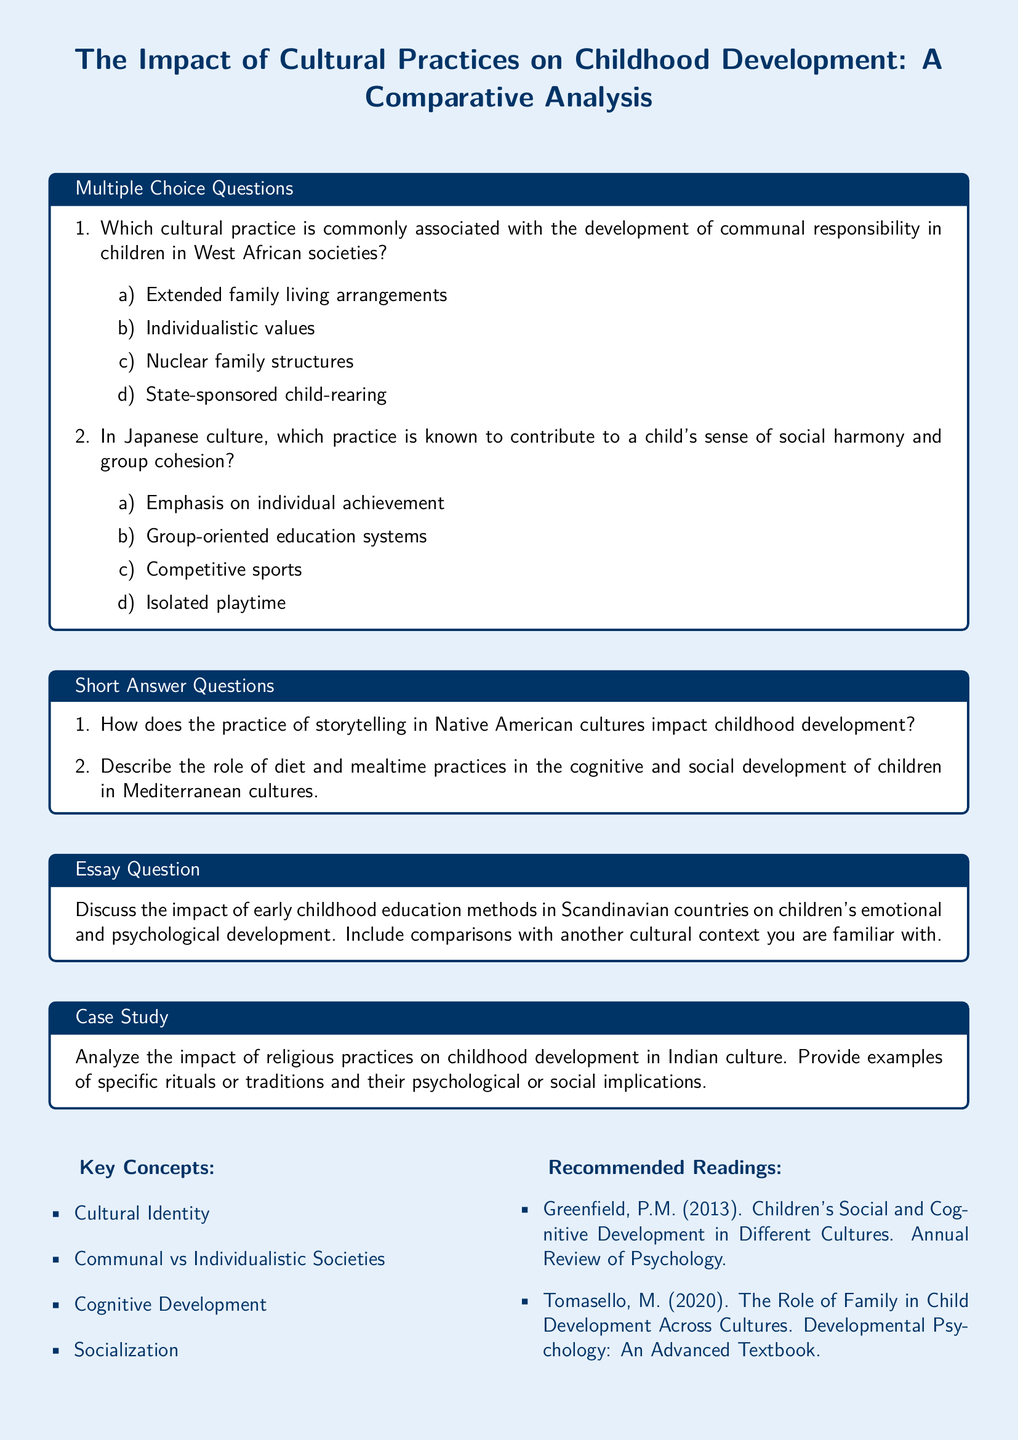What is the title of the document? The title is prominently displayed at the top of the document.
Answer: The Impact of Cultural Practices on Childhood Development: A Comparative Analysis How many multiple choice questions are there in the document? The document contains two multiple choice questions under the specified section.
Answer: 2 What cultural practice is associated with communal responsibility in West African societies? This information is found in the first multiple choice question.
Answer: Extended family living arrangements What is emphasized in Japanese culture to contribute to group cohesion? This is stated in the second multiple choice question of the document.
Answer: Group-oriented education systems According to the short answer section, what cultural practice impacts childhood development in Native American cultures? The question addresses the impact of storytelling on childhood development.
Answer: Storytelling Which specific area of development is highlighted in the essay question? The essay question is focused on emotional and psychological development in the context of early education.
Answer: Emotional and psychological development What type of analysis is requested in the case study section of the document? The case study requires an analysis of religious practices in relation to childhood development.
Answer: Religious practices What type of societal structures are compared in the key concepts section? The key concepts are categorizing societies for comparative purposes.
Answer: Communal vs Individualistic Societies 